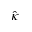Convert formula to latex. <formula><loc_0><loc_0><loc_500><loc_500>\hat { \kappa }</formula> 